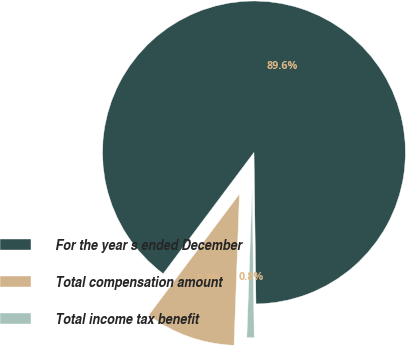Convert chart to OTSL. <chart><loc_0><loc_0><loc_500><loc_500><pie_chart><fcel>For the year s ended December<fcel>Total compensation amount<fcel>Total income tax benefit<nl><fcel>89.56%<fcel>9.66%<fcel>0.78%<nl></chart> 